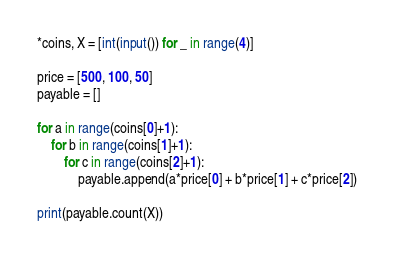Convert code to text. <code><loc_0><loc_0><loc_500><loc_500><_Python_>*coins, X = [int(input()) for _ in range(4)]

price = [500, 100, 50]
payable = []

for a in range(coins[0]+1):
    for b in range(coins[1]+1):
        for c in range(coins[2]+1):
            payable.append(a*price[0] + b*price[1] + c*price[2])
            
print(payable.count(X))</code> 